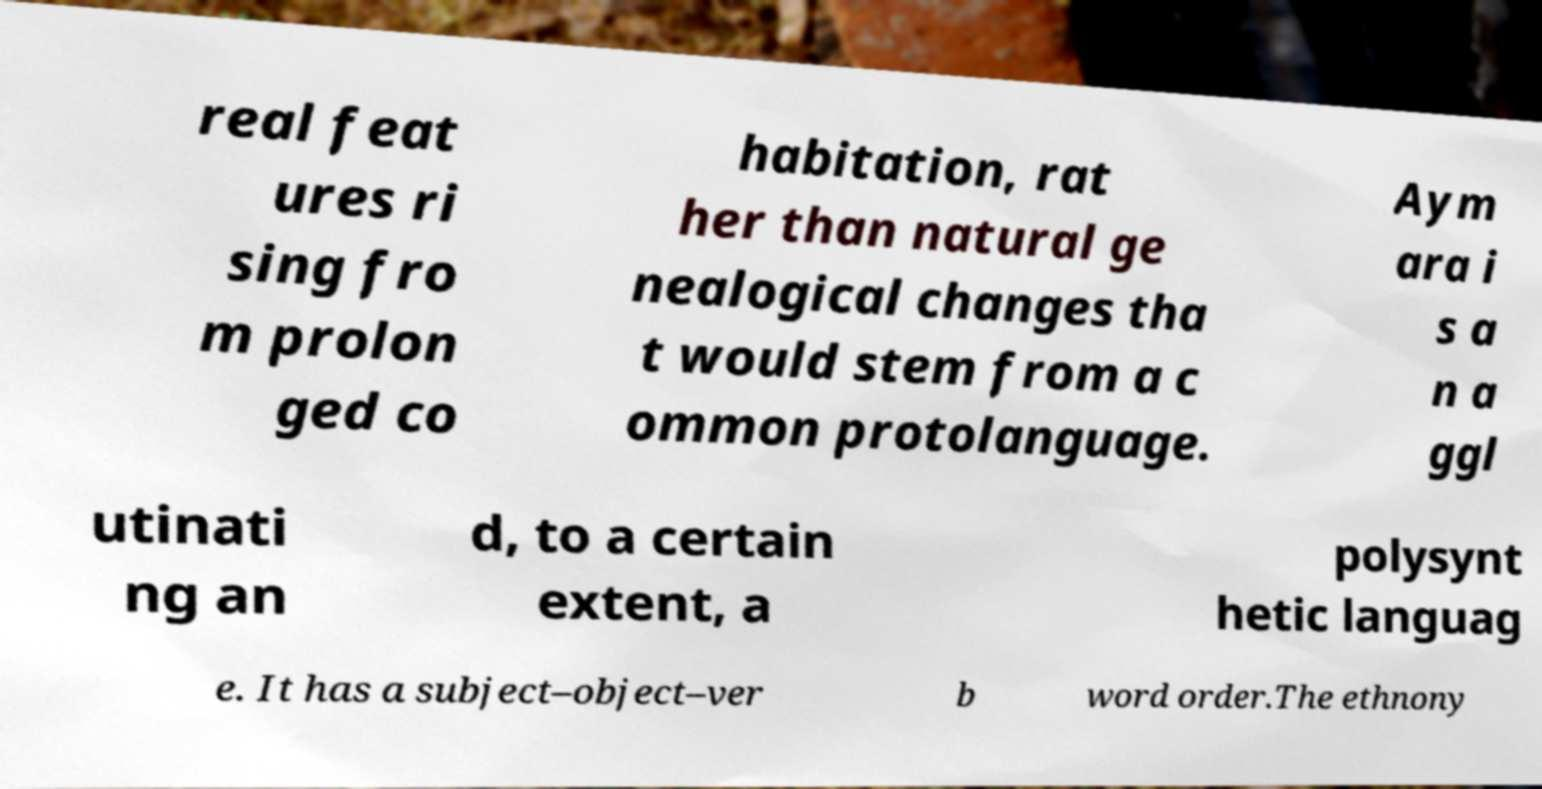For documentation purposes, I need the text within this image transcribed. Could you provide that? real feat ures ri sing fro m prolon ged co habitation, rat her than natural ge nealogical changes tha t would stem from a c ommon protolanguage. Aym ara i s a n a ggl utinati ng an d, to a certain extent, a polysynt hetic languag e. It has a subject–object–ver b word order.The ethnony 